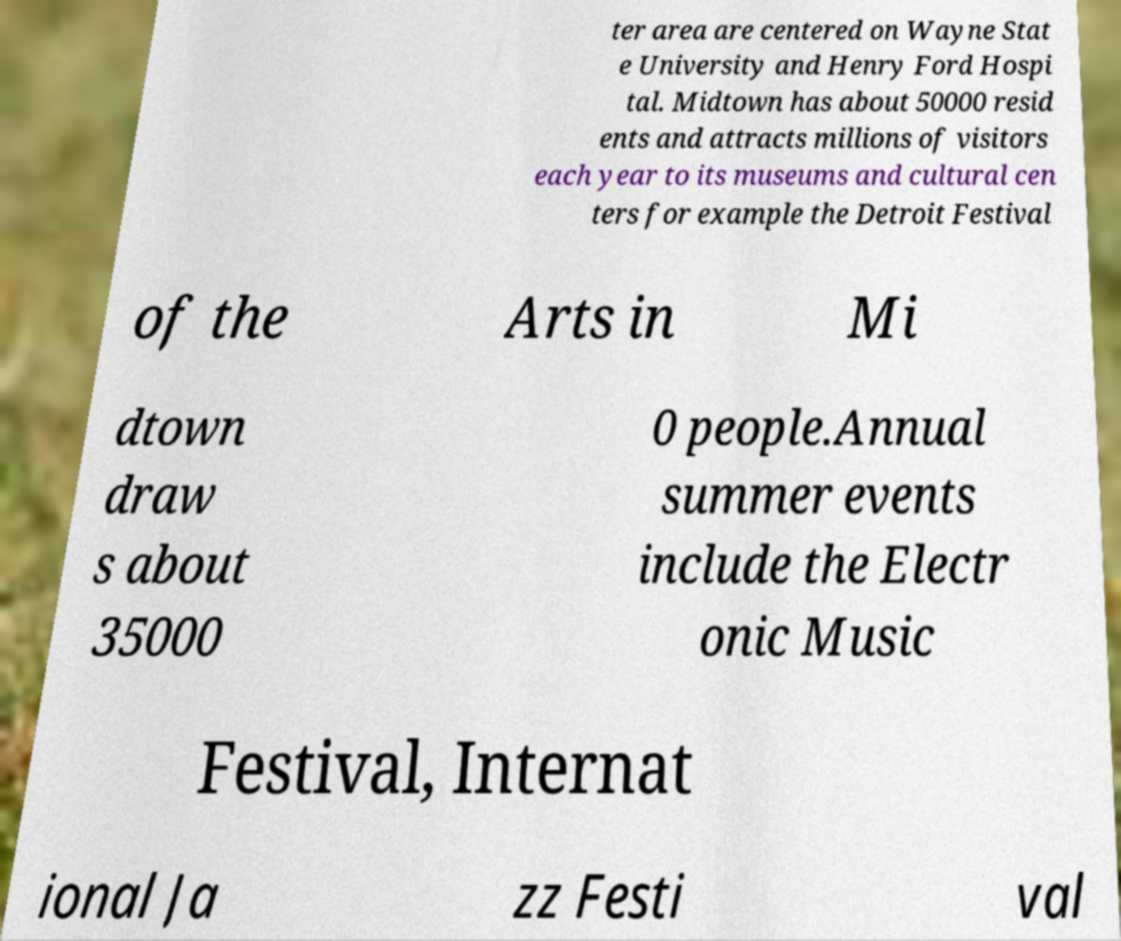There's text embedded in this image that I need extracted. Can you transcribe it verbatim? ter area are centered on Wayne Stat e University and Henry Ford Hospi tal. Midtown has about 50000 resid ents and attracts millions of visitors each year to its museums and cultural cen ters for example the Detroit Festival of the Arts in Mi dtown draw s about 35000 0 people.Annual summer events include the Electr onic Music Festival, Internat ional Ja zz Festi val 